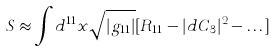<formula> <loc_0><loc_0><loc_500><loc_500>S \approx \int d ^ { 1 1 } x \sqrt { | g _ { 1 1 } | } [ R _ { 1 1 } - | d C _ { 3 } | ^ { 2 } - \dots ]</formula> 